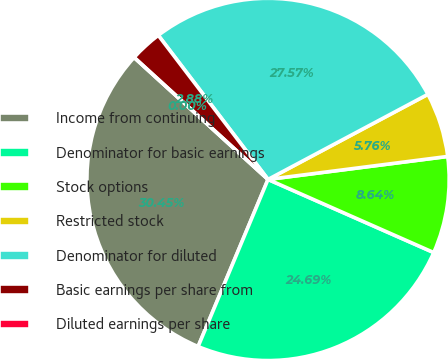<chart> <loc_0><loc_0><loc_500><loc_500><pie_chart><fcel>Income from continuing<fcel>Denominator for basic earnings<fcel>Stock options<fcel>Restricted stock<fcel>Denominator for diluted<fcel>Basic earnings per share from<fcel>Diluted earnings per share<nl><fcel>30.45%<fcel>24.69%<fcel>8.64%<fcel>5.76%<fcel>27.57%<fcel>2.88%<fcel>0.0%<nl></chart> 